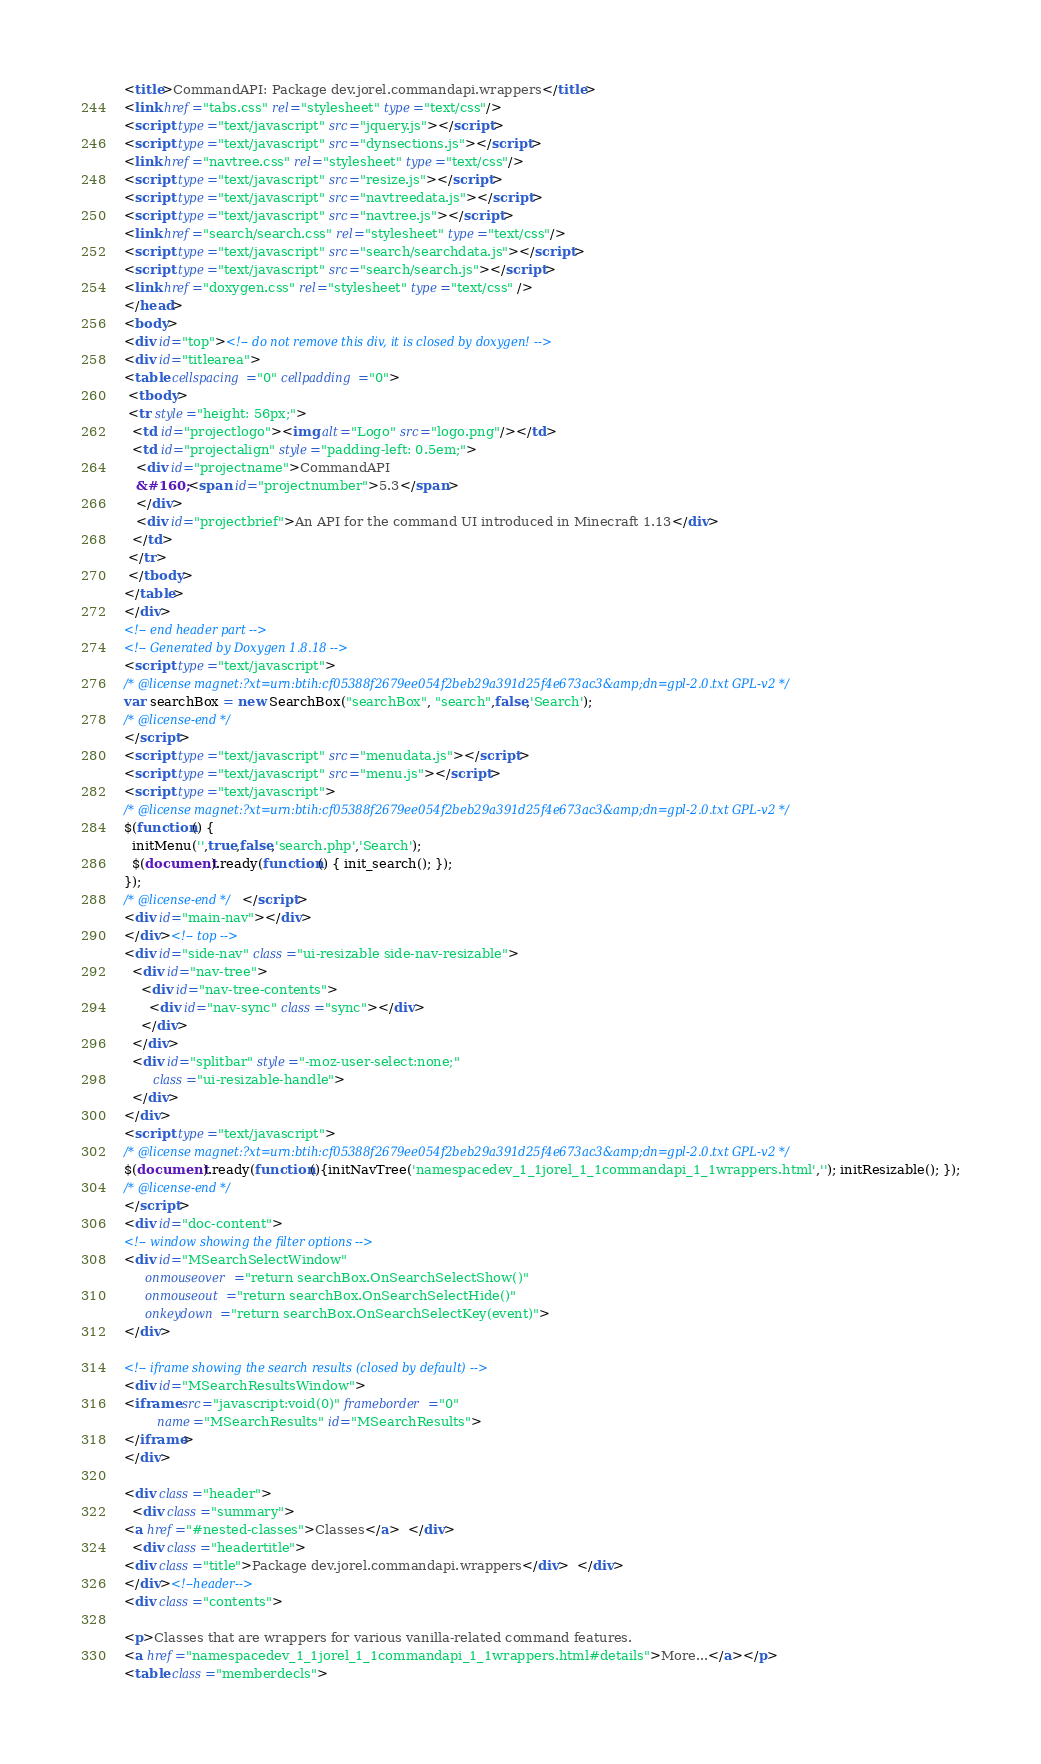Convert code to text. <code><loc_0><loc_0><loc_500><loc_500><_HTML_><title>CommandAPI: Package dev.jorel.commandapi.wrappers</title>
<link href="tabs.css" rel="stylesheet" type="text/css"/>
<script type="text/javascript" src="jquery.js"></script>
<script type="text/javascript" src="dynsections.js"></script>
<link href="navtree.css" rel="stylesheet" type="text/css"/>
<script type="text/javascript" src="resize.js"></script>
<script type="text/javascript" src="navtreedata.js"></script>
<script type="text/javascript" src="navtree.js"></script>
<link href="search/search.css" rel="stylesheet" type="text/css"/>
<script type="text/javascript" src="search/searchdata.js"></script>
<script type="text/javascript" src="search/search.js"></script>
<link href="doxygen.css" rel="stylesheet" type="text/css" />
</head>
<body>
<div id="top"><!-- do not remove this div, it is closed by doxygen! -->
<div id="titlearea">
<table cellspacing="0" cellpadding="0">
 <tbody>
 <tr style="height: 56px;">
  <td id="projectlogo"><img alt="Logo" src="logo.png"/></td>
  <td id="projectalign" style="padding-left: 0.5em;">
   <div id="projectname">CommandAPI
   &#160;<span id="projectnumber">5.3</span>
   </div>
   <div id="projectbrief">An API for the command UI introduced in Minecraft 1.13</div>
  </td>
 </tr>
 </tbody>
</table>
</div>
<!-- end header part -->
<!-- Generated by Doxygen 1.8.18 -->
<script type="text/javascript">
/* @license magnet:?xt=urn:btih:cf05388f2679ee054f2beb29a391d25f4e673ac3&amp;dn=gpl-2.0.txt GPL-v2 */
var searchBox = new SearchBox("searchBox", "search",false,'Search');
/* @license-end */
</script>
<script type="text/javascript" src="menudata.js"></script>
<script type="text/javascript" src="menu.js"></script>
<script type="text/javascript">
/* @license magnet:?xt=urn:btih:cf05388f2679ee054f2beb29a391d25f4e673ac3&amp;dn=gpl-2.0.txt GPL-v2 */
$(function() {
  initMenu('',true,false,'search.php','Search');
  $(document).ready(function() { init_search(); });
});
/* @license-end */</script>
<div id="main-nav"></div>
</div><!-- top -->
<div id="side-nav" class="ui-resizable side-nav-resizable">
  <div id="nav-tree">
    <div id="nav-tree-contents">
      <div id="nav-sync" class="sync"></div>
    </div>
  </div>
  <div id="splitbar" style="-moz-user-select:none;" 
       class="ui-resizable-handle">
  </div>
</div>
<script type="text/javascript">
/* @license magnet:?xt=urn:btih:cf05388f2679ee054f2beb29a391d25f4e673ac3&amp;dn=gpl-2.0.txt GPL-v2 */
$(document).ready(function(){initNavTree('namespacedev_1_1jorel_1_1commandapi_1_1wrappers.html',''); initResizable(); });
/* @license-end */
</script>
<div id="doc-content">
<!-- window showing the filter options -->
<div id="MSearchSelectWindow"
     onmouseover="return searchBox.OnSearchSelectShow()"
     onmouseout="return searchBox.OnSearchSelectHide()"
     onkeydown="return searchBox.OnSearchSelectKey(event)">
</div>

<!-- iframe showing the search results (closed by default) -->
<div id="MSearchResultsWindow">
<iframe src="javascript:void(0)" frameborder="0" 
        name="MSearchResults" id="MSearchResults">
</iframe>
</div>

<div class="header">
  <div class="summary">
<a href="#nested-classes">Classes</a>  </div>
  <div class="headertitle">
<div class="title">Package dev.jorel.commandapi.wrappers</div>  </div>
</div><!--header-->
<div class="contents">

<p>Classes that are wrappers for various vanilla-related command features.  
<a href="namespacedev_1_1jorel_1_1commandapi_1_1wrappers.html#details">More...</a></p>
<table class="memberdecls"></code> 